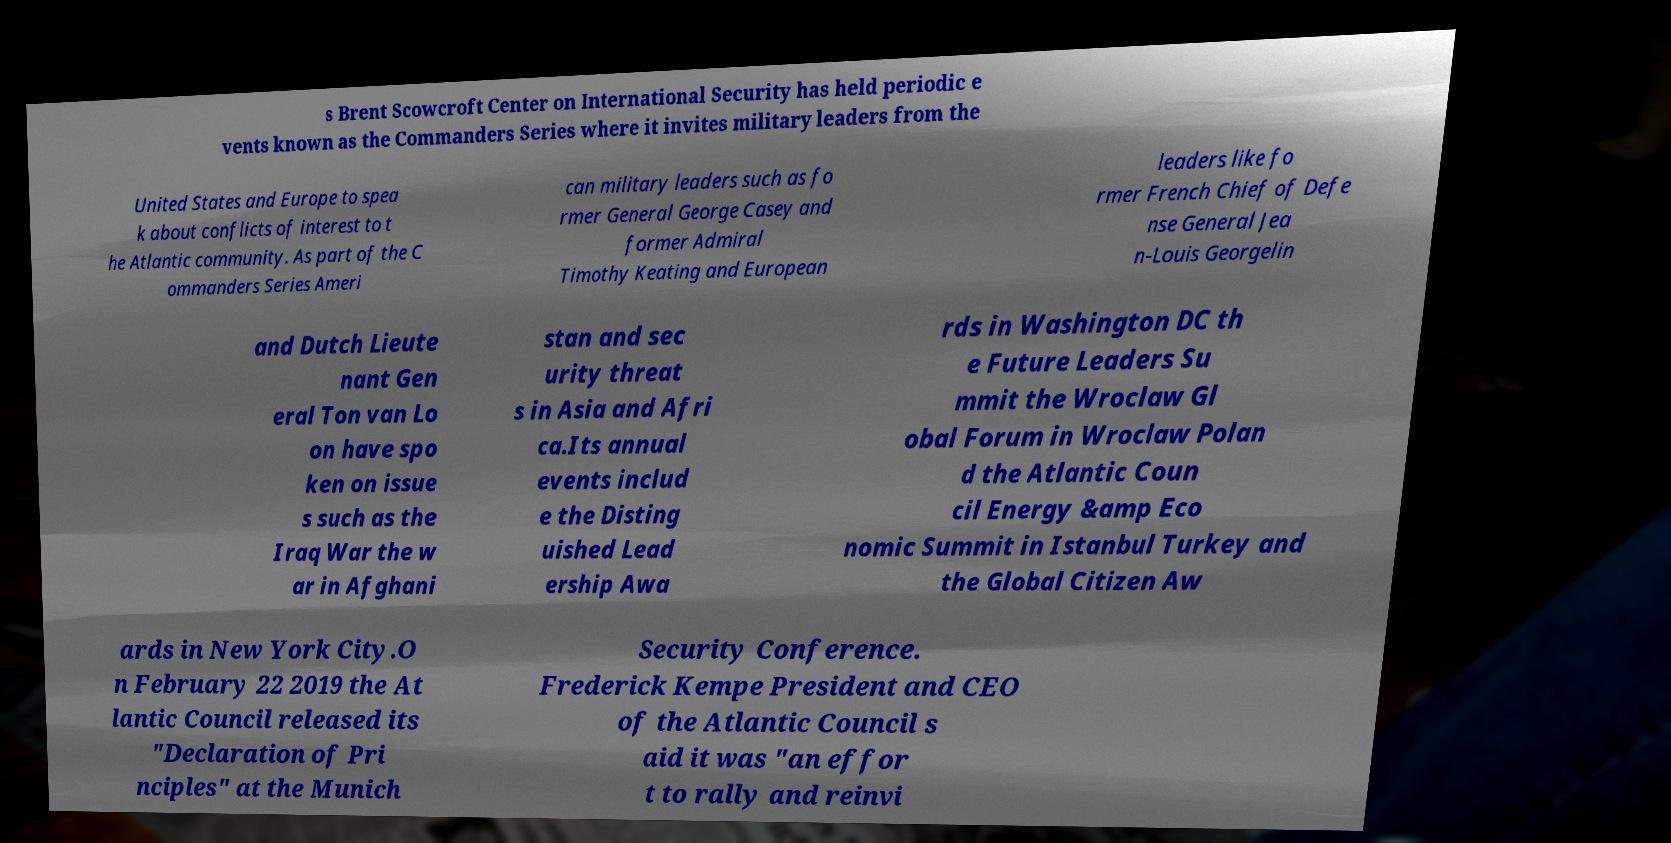Can you accurately transcribe the text from the provided image for me? s Brent Scowcroft Center on International Security has held periodic e vents known as the Commanders Series where it invites military leaders from the United States and Europe to spea k about conflicts of interest to t he Atlantic community. As part of the C ommanders Series Ameri can military leaders such as fo rmer General George Casey and former Admiral Timothy Keating and European leaders like fo rmer French Chief of Defe nse General Jea n-Louis Georgelin and Dutch Lieute nant Gen eral Ton van Lo on have spo ken on issue s such as the Iraq War the w ar in Afghani stan and sec urity threat s in Asia and Afri ca.Its annual events includ e the Disting uished Lead ership Awa rds in Washington DC th e Future Leaders Su mmit the Wroclaw Gl obal Forum in Wroclaw Polan d the Atlantic Coun cil Energy &amp Eco nomic Summit in Istanbul Turkey and the Global Citizen Aw ards in New York City.O n February 22 2019 the At lantic Council released its "Declaration of Pri nciples" at the Munich Security Conference. Frederick Kempe President and CEO of the Atlantic Council s aid it was "an effor t to rally and reinvi 